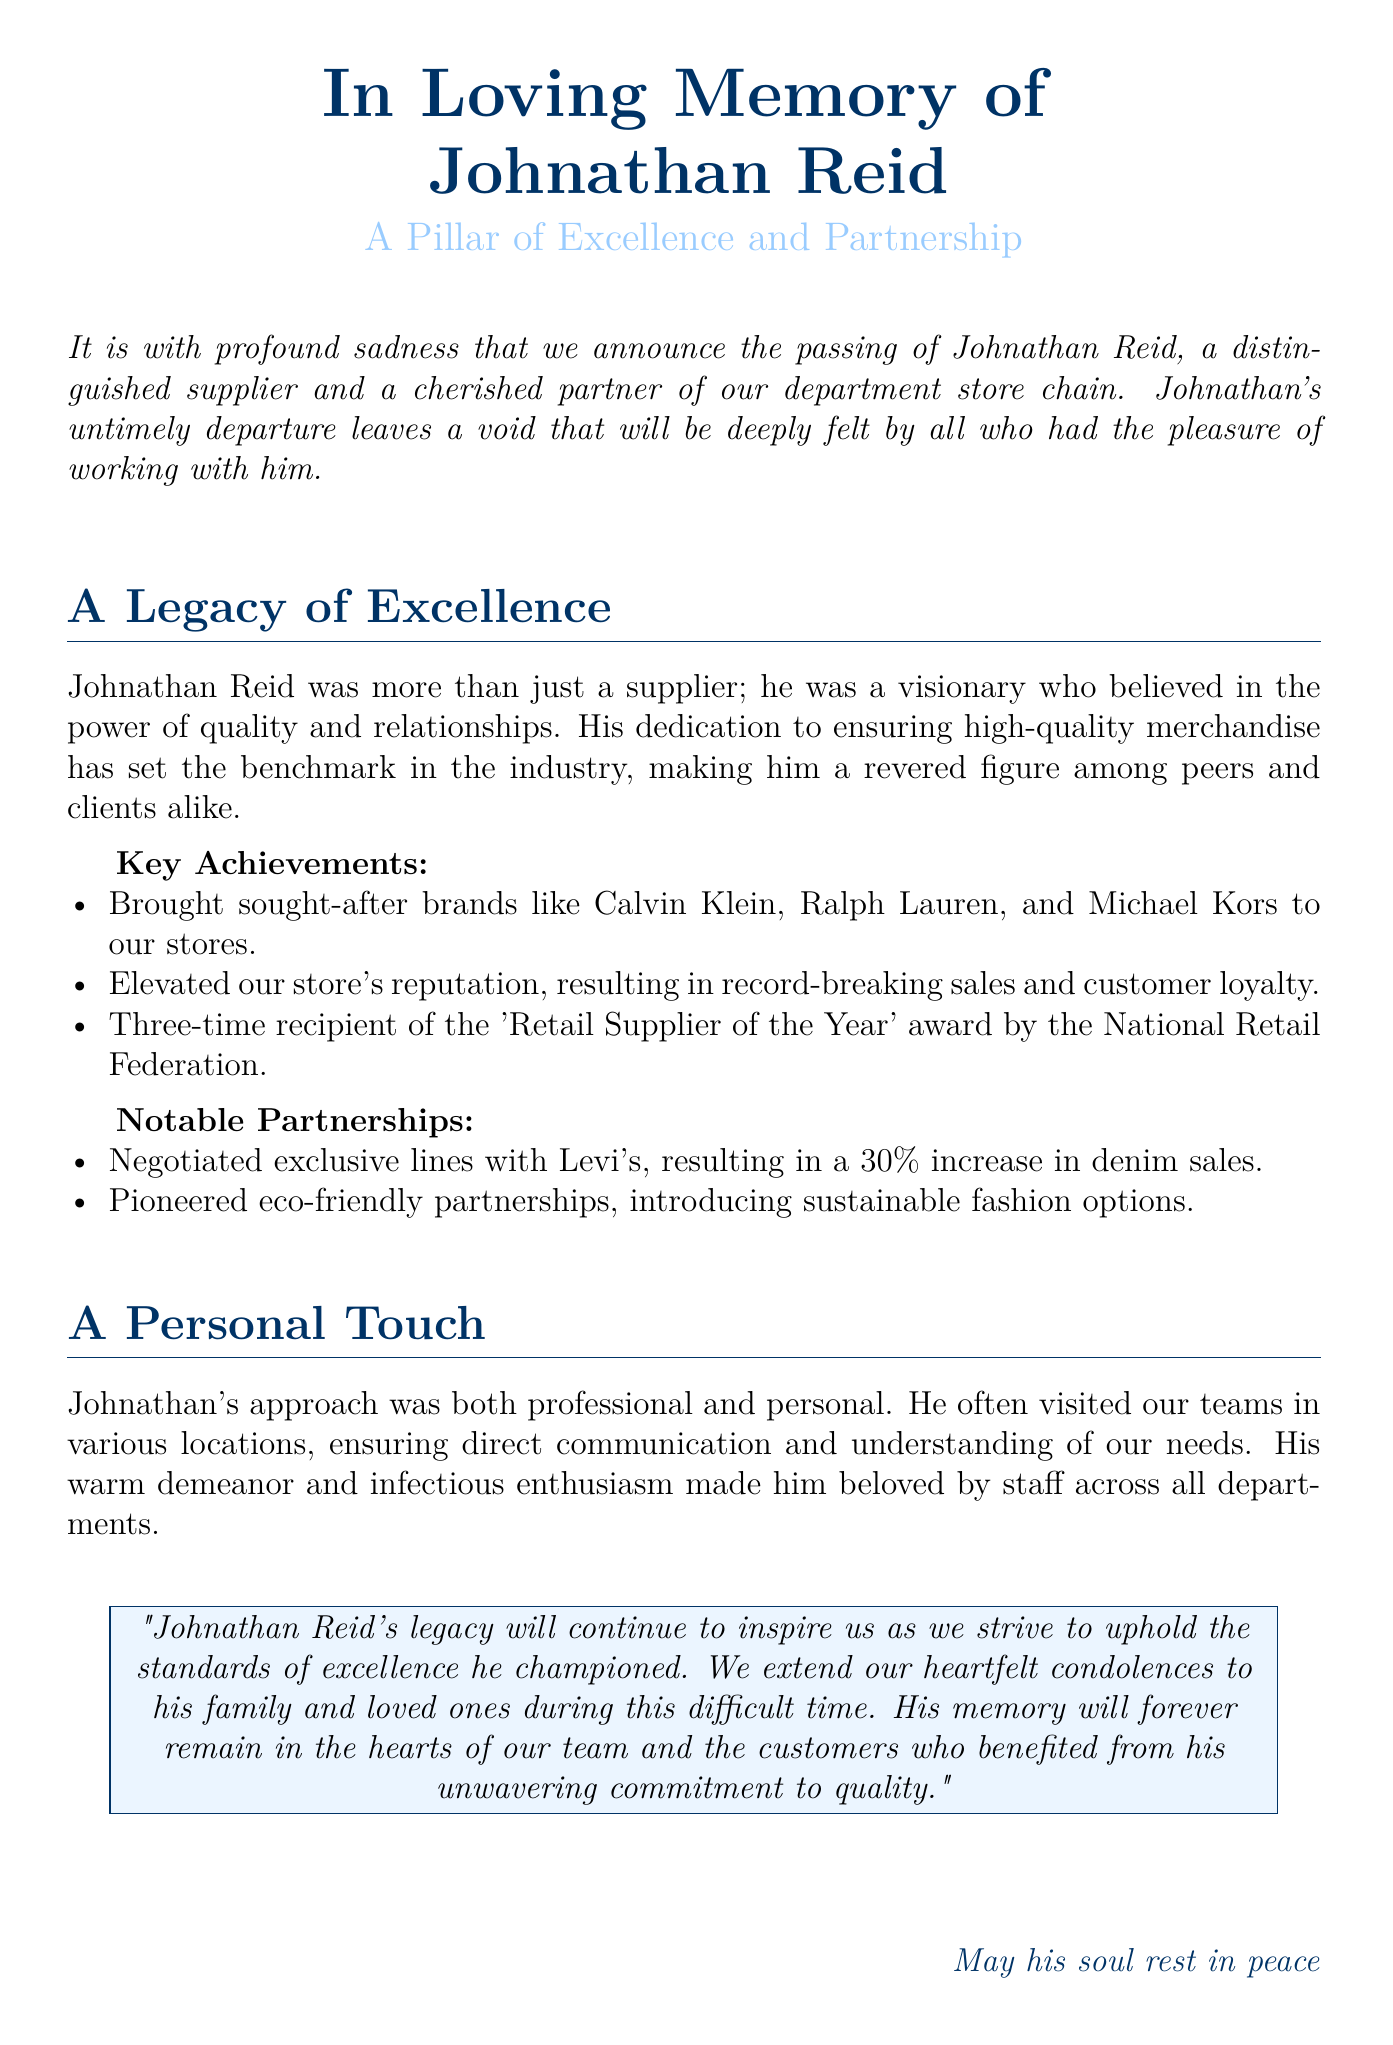What was Johnathan Reid's role? Johnathan Reid was described as a distinguished supplier and cherished partner.
Answer: a distinguished supplier What brands did Johnathan Reid bring to the stores? The document lists Calvin Klein, Ralph Lauren, and Michael Kors as brands he brought.
Answer: Calvin Klein, Ralph Lauren, Michael Kors How many times did Johnathan win the 'Retail Supplier of the Year' award? The document states he was a three-time recipient of the award.
Answer: three times What was the impact of the exclusive lines negotiated with Levi's? It resulted in a 30% increase in denim sales for the store.
Answer: 30% increase in denim sales What is mentioned about Johnathan's approach to business? The document emphasizes that his approach was both professional and personal.
Answer: professional and personal What will Johnathan Reid's legacy inspire? His legacy will inspire the team to uphold the standards of excellence he championed.
Answer: standards of excellence What type of partnerships did Johnathan pioneer? He pioneered eco-friendly partnerships for introducing sustainable fashion options.
Answer: eco-friendly partnerships What is expressed towards Johnathan's family in the document? The document extends heartfelt condolences to his family and loved ones.
Answer: heartfelt condolences 